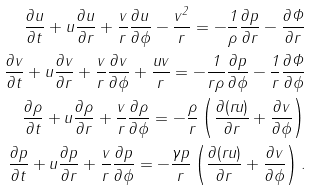Convert formula to latex. <formula><loc_0><loc_0><loc_500><loc_500>\frac { \partial u } { \partial t } + u \frac { \partial u } { \partial r } + \frac { v } { r } \frac { \partial u } { \partial \phi } - \frac { v ^ { 2 } } { r } = - \frac { 1 } { \rho } \frac { \partial p } { \partial r } - \frac { \partial \Phi } { \partial r } \\ \frac { \partial v } { \partial t } + u \frac { \partial v } { \partial r } + \frac { v } { r } \frac { \partial v } { \partial \phi } + \frac { u v } { r } = - \frac { 1 } { r \rho } \frac { \partial p } { \partial \phi } - \frac { 1 } { r } \frac { \partial \Phi } { \partial \phi } \\ \frac { \partial \rho } { \partial t } + u \frac { \partial \rho } { \partial r } + \frac { v } { r } \frac { \partial \rho } { \partial \phi } = - \frac { \rho } { r } \left ( \frac { \partial ( r u ) } { \partial r } + \frac { \partial v } { \partial \phi } \right ) \\ \frac { \partial p } { \partial t } + u \frac { \partial p } { \partial r } + \frac { v } { r } \frac { \partial p } { \partial \phi } = - \frac { \gamma p } { r } \left ( \frac { \partial ( r u ) } { \partial r } + \frac { \partial v } { \partial \phi } \right ) .</formula> 